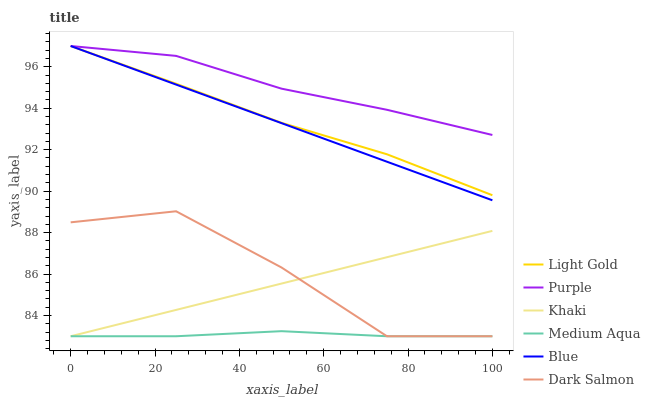Does Medium Aqua have the minimum area under the curve?
Answer yes or no. Yes. Does Purple have the maximum area under the curve?
Answer yes or no. Yes. Does Khaki have the minimum area under the curve?
Answer yes or no. No. Does Khaki have the maximum area under the curve?
Answer yes or no. No. Is Blue the smoothest?
Answer yes or no. Yes. Is Dark Salmon the roughest?
Answer yes or no. Yes. Is Purple the smoothest?
Answer yes or no. No. Is Purple the roughest?
Answer yes or no. No. Does Purple have the lowest value?
Answer yes or no. No. Does Khaki have the highest value?
Answer yes or no. No. Is Dark Salmon less than Light Gold?
Answer yes or no. Yes. Is Purple greater than Dark Salmon?
Answer yes or no. Yes. Does Dark Salmon intersect Light Gold?
Answer yes or no. No. 